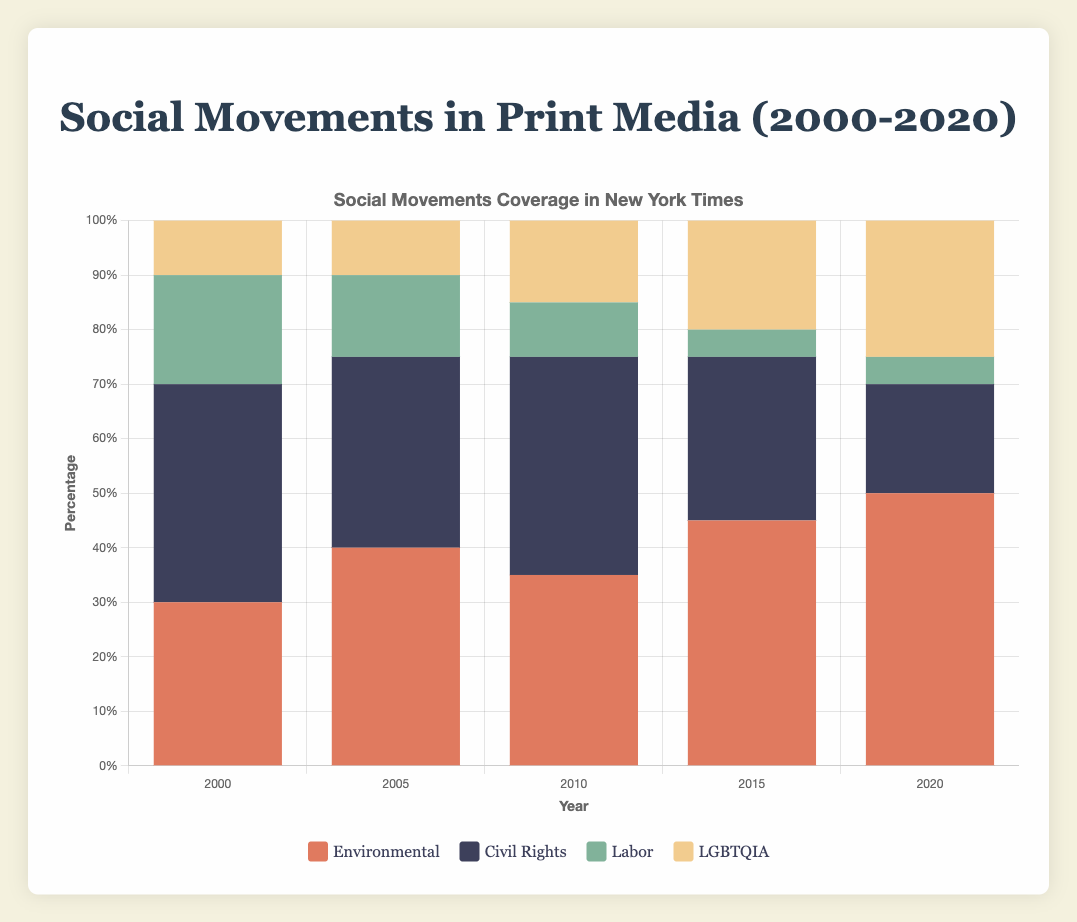What social movement had the highest representation in the New York Times in 2020? To determine this, look at the stacked bar representing 2020 for the New York Times and identify the section with the greatest height. The environmental movement is the tallest bar.
Answer: Environmental How does the representation of civil rights movements in the Washington Post change from 2000 to 2020? Inspect the heights of the civil rights segments (usually colored grey) within the Washington Post bars over the years 2000 to 2020. It starts at 30% in 2000 and decreases to 20% by 2020.
Answer: Decreases What percentage of representation did the labor movement have in the Guardian in 2005? Locate the bar for 2005 for the Guardian and the segment corresponding to the labor movement. The label indicates it is 30%.
Answer: 30% Which news outlet had the highest coverage of LGBTQIA movements in 2015? Compare the bar segments colored typically light yellow for 2015 across all news outlets. The Guardian has a 25% coverage, which is the highest.
Answer: The Guardian By how many percentage points did the environmental movement coverage in the New York Times increase from 2000 to 2020? Calculate the difference in the environmental bar segments (usually colored red) in 2020 and 2000. It increases from 30% in 2000 to 50% in 2020, giving a difference of 50% - 30% = 20%.
Answer: 20% Which year had the highest overall coverage for environmental movements across all major print media? Sum up the environmental segments for each year across all three newspapers and identify the year with the highest total. 2020 has the highest with NY Times (50%), Washington Post (55%), and The Guardian (45%), totaling 150%.
Answer: 2020 How does LGBTQIA movement coverage in the Washington Post change from 2005 to 2015? Look at the stacked bars for Washington Post in 2005 and 2015. The light yellow segment representing LGBTQIA is at 10% in 2005 and increases to 20% in 2015.
Answer: Increases Which type of social movement sees the most consistent coverage across the New York Times, Washington Post, and The Guardian in 2010? For 2010, compare the coverage segments across all outlets. Environmental and Civil Rights movements both have equal or relatively similar coverage (around 35-40%), but Labor has the most consistent at 10-15% across all outlets.
Answer: Labor What is the total representation percentage for labor movements across all three newspapers in 2000? Sum up the labor segments from New York Times (20%), Washington Post (25%), and The Guardian (30%). The total is 20% + 25% + 30% = 75%.
Answer: 75% 